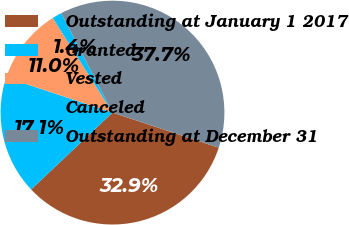<chart> <loc_0><loc_0><loc_500><loc_500><pie_chart><fcel>Outstanding at January 1 2017<fcel>Granted<fcel>Vested<fcel>Canceled<fcel>Outstanding at December 31<nl><fcel>32.87%<fcel>17.13%<fcel>10.96%<fcel>1.38%<fcel>37.65%<nl></chart> 